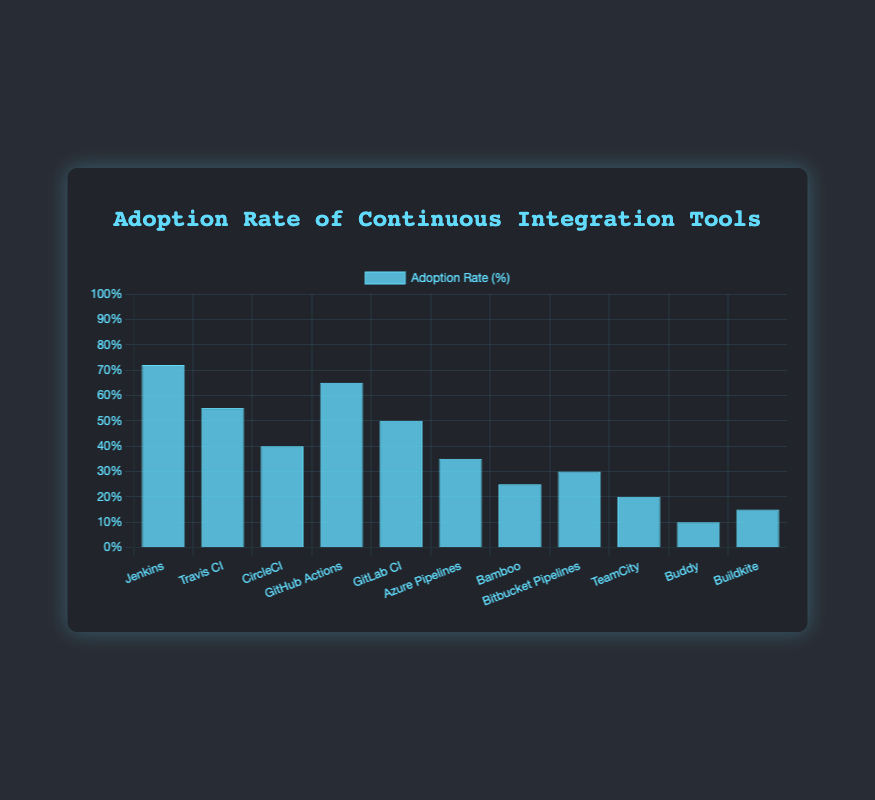What is the most widely adopted CI tool among the development teams? By observing the height of the bars, Jenkins has the tallest bar, indicating it has the highest adoption rate among the listed CI tools at 72%.
Answer: Jenkins Which CI tool has a lower adoption rate: GitHub Actions or GitLab CI? GitHub Actions has an adoption rate of 65%, while GitLab CI has an adoption rate of 50%. Comparing these values, GitLab CI has a lower adoption rate.
Answer: GitLab CI What is the combined adoption rate of Travis CI and CircleCI? The adoption rate for Travis CI is 55% and for CircleCI is 40%. Summing these values, 55% + 40% = 95%.
Answer: 95% Which CI tool has the smallest adoption rate and what is it? By observing the height of the bars, Buddy has the shortest bar, indicating it has the lowest adoption rate at 10%.
Answer: Buddy Is the adoption rate of Azure Pipelines greater than or less than Bitbucket Pipelines? Azure Pipelines has an adoption rate of 35%, and Bitbucket Pipelines has an adoption rate of 30%. Thus, Azure Pipelines has a greater adoption rate than Bitbucket Pipelines.
Answer: Greater than How many CI tools have an adoption rate greater than 50%? The tools with adoption rates greater than 50% are Jenkins (72%), Travis CI (55%), and GitHub Actions (65%). Thus, 3 CI tools have an adoption rate greater than 50%.
Answer: 3 What's the difference in the adoption rate between the most and least adopted CI tools? The most adopted CI tool is Jenkins (72%), and the least adopted is Buddy (10%). The difference is 72% - 10% = 62%.
Answer: 62% If you combine the adoption rates of the three least adopted CI tools, what is their total adoption rate? The three least adopted CI tools are Buddy (10%), Buildkite (15%), and TeamCity (20%). Their combined adoption rate is 10% + 15% + 20% = 45%.
Answer: 45% How does the adoption rate of Jenkins compare to the average adoption rate of all CI tools? To find the average adoption rate, sum all rates and divide by the number of tools: (72 + 55 + 40 + 65 + 50 + 35 + 25 + 30 + 20 + 10 + 15) / 11 = 37.6%. Jenkins has an adoption rate of 72%, which is significantly higher than the average of 37.6%.
Answer: Higher Which CI tools have an adoption rate of at least 40% but not more than 60%? The CI tools within the 40%-60% range are Travis CI (55%), CircleCI (40%), and GitLab CI (50%).
Answer: Travis CI, CircleCI, GitLab CI 